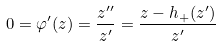<formula> <loc_0><loc_0><loc_500><loc_500>0 = \varphi ^ { \prime } ( z ) = \frac { z ^ { \prime \prime } } { z ^ { \prime } } = \frac { z - h _ { + } ( z ^ { \prime } ) } { z ^ { \prime } }</formula> 